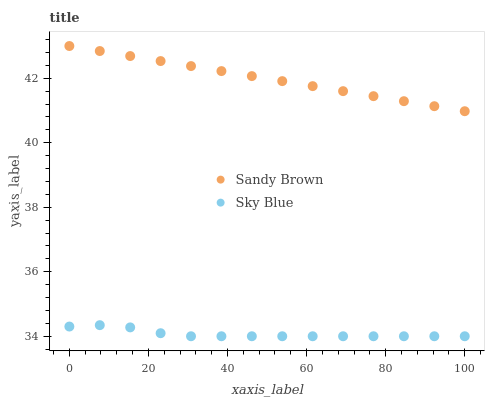Does Sky Blue have the minimum area under the curve?
Answer yes or no. Yes. Does Sandy Brown have the maximum area under the curve?
Answer yes or no. Yes. Does Sandy Brown have the minimum area under the curve?
Answer yes or no. No. Is Sandy Brown the smoothest?
Answer yes or no. Yes. Is Sky Blue the roughest?
Answer yes or no. Yes. Is Sandy Brown the roughest?
Answer yes or no. No. Does Sky Blue have the lowest value?
Answer yes or no. Yes. Does Sandy Brown have the lowest value?
Answer yes or no. No. Does Sandy Brown have the highest value?
Answer yes or no. Yes. Is Sky Blue less than Sandy Brown?
Answer yes or no. Yes. Is Sandy Brown greater than Sky Blue?
Answer yes or no. Yes. Does Sky Blue intersect Sandy Brown?
Answer yes or no. No. 